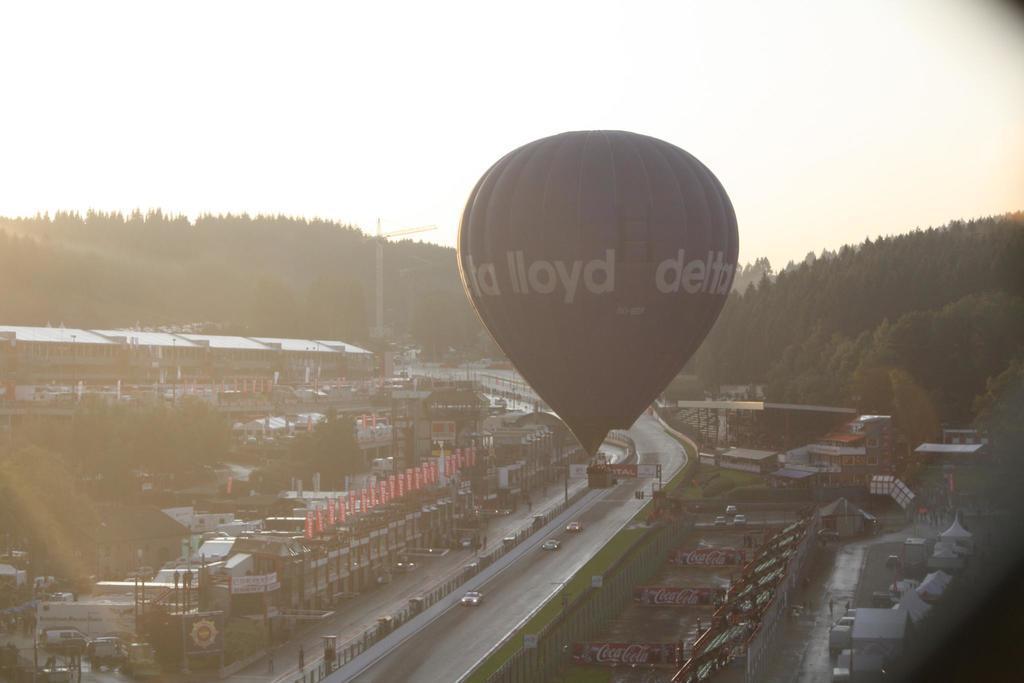In one or two sentences, can you explain what this image depicts? In this picture we can see the parachute in middle of the image. At the bottom side there is a road and some cars are moving. On the left side there are some houses and building. In the background we can see some trees. 